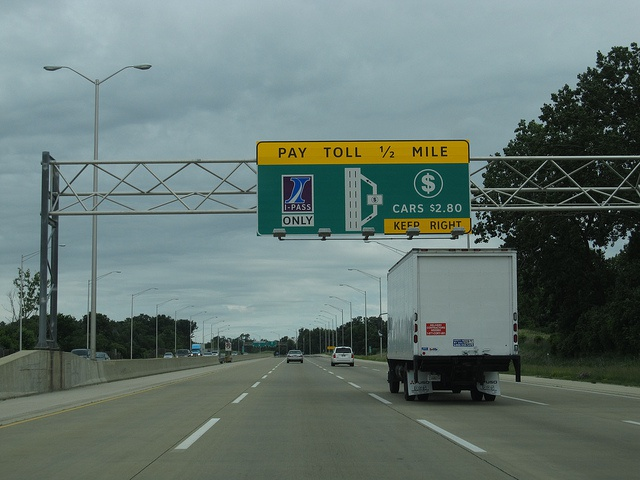Describe the objects in this image and their specific colors. I can see truck in darkgray, gray, and black tones, car in darkgray, black, and gray tones, car in darkgray, gray, black, and teal tones, car in darkgray, black, gray, purple, and darkblue tones, and truck in darkgray, teal, black, and purple tones in this image. 